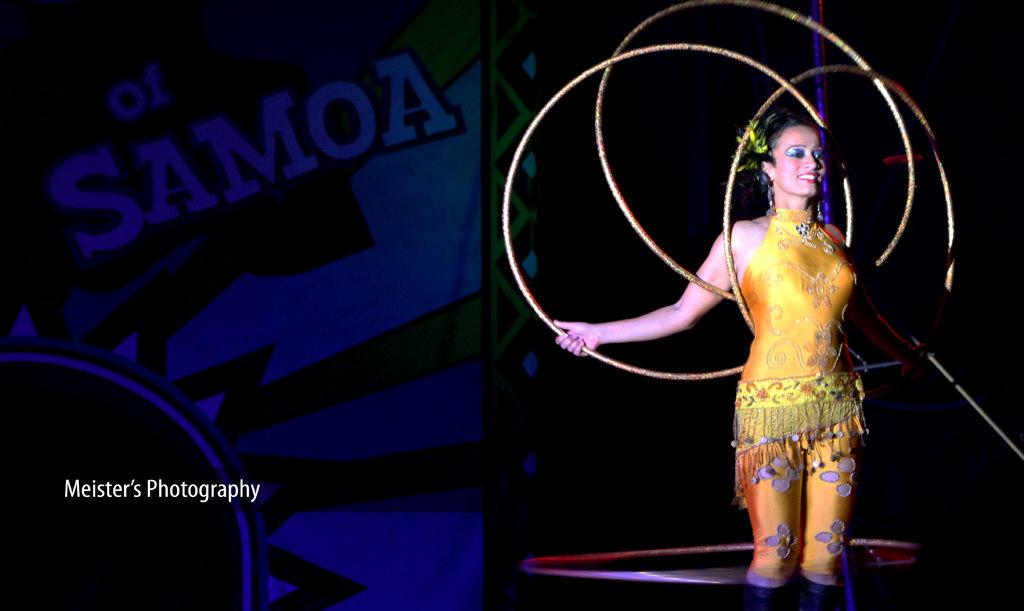What is the woman doing on the right side of the image? The woman is holding rings on the right side of the image. What is the woman's facial expression in the image? The woman is smiling in the image. What can be seen in the background of the image? There is a banner in the background of the image. What is present on the left side of the image? There is text on the left side of the image. What instrument is the woman using to copy the rings in the image? There is no instrument present in the image, and the woman is not copying the rings. 